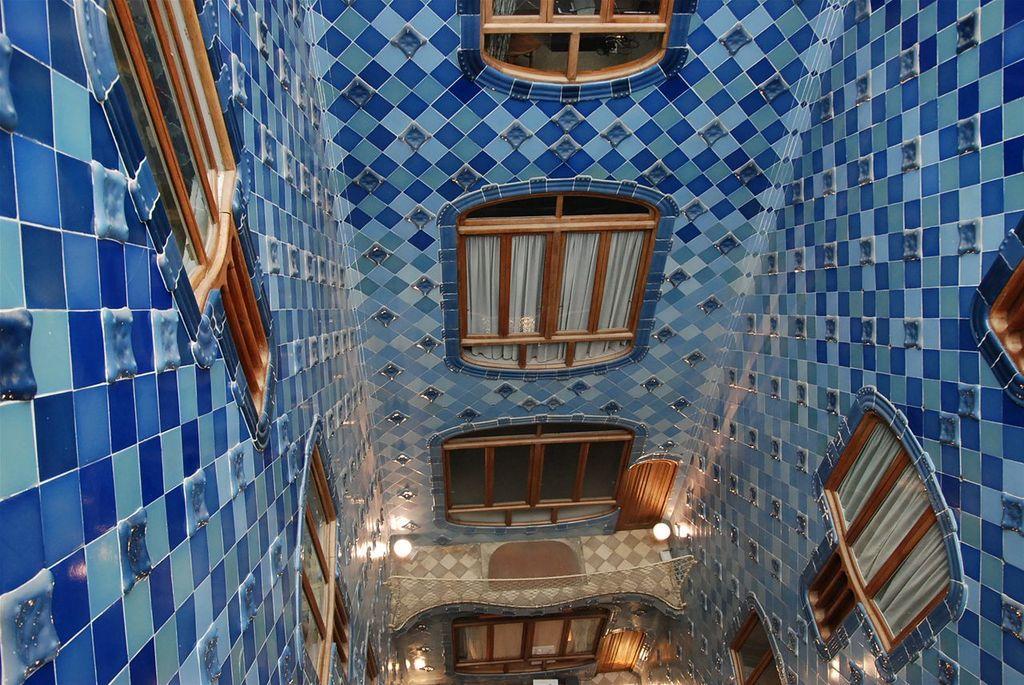Please provide a concise description of this image. This is an inside picture of a room, on the walls we can see some windows, at the top of the roof we can see some lights. 